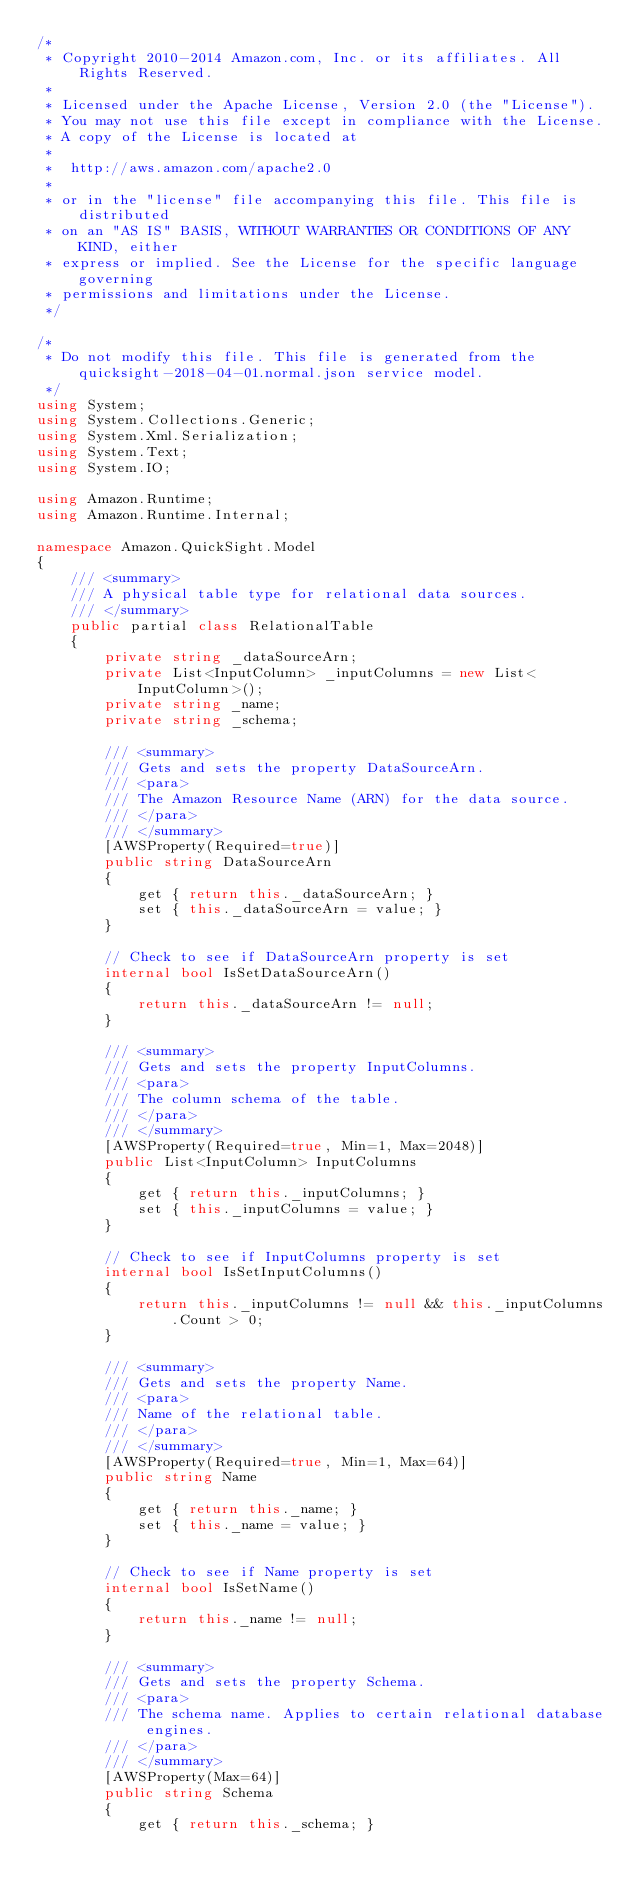Convert code to text. <code><loc_0><loc_0><loc_500><loc_500><_C#_>/*
 * Copyright 2010-2014 Amazon.com, Inc. or its affiliates. All Rights Reserved.
 * 
 * Licensed under the Apache License, Version 2.0 (the "License").
 * You may not use this file except in compliance with the License.
 * A copy of the License is located at
 * 
 *  http://aws.amazon.com/apache2.0
 * 
 * or in the "license" file accompanying this file. This file is distributed
 * on an "AS IS" BASIS, WITHOUT WARRANTIES OR CONDITIONS OF ANY KIND, either
 * express or implied. See the License for the specific language governing
 * permissions and limitations under the License.
 */

/*
 * Do not modify this file. This file is generated from the quicksight-2018-04-01.normal.json service model.
 */
using System;
using System.Collections.Generic;
using System.Xml.Serialization;
using System.Text;
using System.IO;

using Amazon.Runtime;
using Amazon.Runtime.Internal;

namespace Amazon.QuickSight.Model
{
    /// <summary>
    /// A physical table type for relational data sources.
    /// </summary>
    public partial class RelationalTable
    {
        private string _dataSourceArn;
        private List<InputColumn> _inputColumns = new List<InputColumn>();
        private string _name;
        private string _schema;

        /// <summary>
        /// Gets and sets the property DataSourceArn. 
        /// <para>
        /// The Amazon Resource Name (ARN) for the data source.
        /// </para>
        /// </summary>
        [AWSProperty(Required=true)]
        public string DataSourceArn
        {
            get { return this._dataSourceArn; }
            set { this._dataSourceArn = value; }
        }

        // Check to see if DataSourceArn property is set
        internal bool IsSetDataSourceArn()
        {
            return this._dataSourceArn != null;
        }

        /// <summary>
        /// Gets and sets the property InputColumns. 
        /// <para>
        /// The column schema of the table.
        /// </para>
        /// </summary>
        [AWSProperty(Required=true, Min=1, Max=2048)]
        public List<InputColumn> InputColumns
        {
            get { return this._inputColumns; }
            set { this._inputColumns = value; }
        }

        // Check to see if InputColumns property is set
        internal bool IsSetInputColumns()
        {
            return this._inputColumns != null && this._inputColumns.Count > 0; 
        }

        /// <summary>
        /// Gets and sets the property Name. 
        /// <para>
        /// Name of the relational table.
        /// </para>
        /// </summary>
        [AWSProperty(Required=true, Min=1, Max=64)]
        public string Name
        {
            get { return this._name; }
            set { this._name = value; }
        }

        // Check to see if Name property is set
        internal bool IsSetName()
        {
            return this._name != null;
        }

        /// <summary>
        /// Gets and sets the property Schema. 
        /// <para>
        /// The schema name. Applies to certain relational database engines.
        /// </para>
        /// </summary>
        [AWSProperty(Max=64)]
        public string Schema
        {
            get { return this._schema; }</code> 